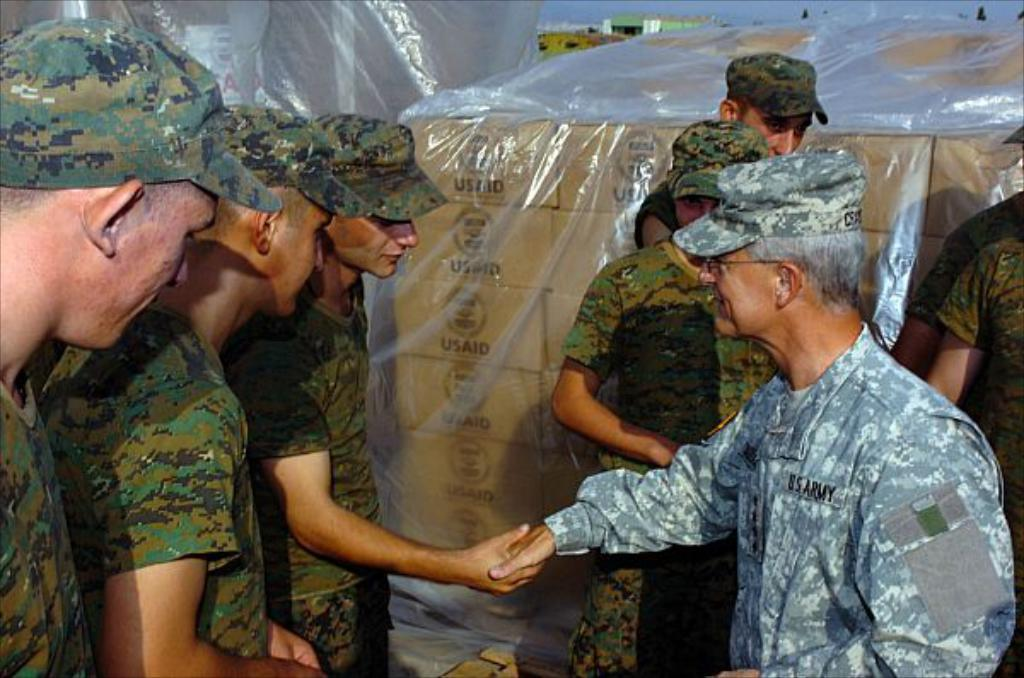What type of people are present in the image? There are army personnel in the image. What are the army personnel doing in the image? The army personnel are shaking hands with each other. What can be seen in the background of the image? There are cardboard boxes in the background of the image. What type of trail can be seen in the image? There is no trail present in the image. What type of farm animals can be seen in the image? There are no farm animals present in the image. 